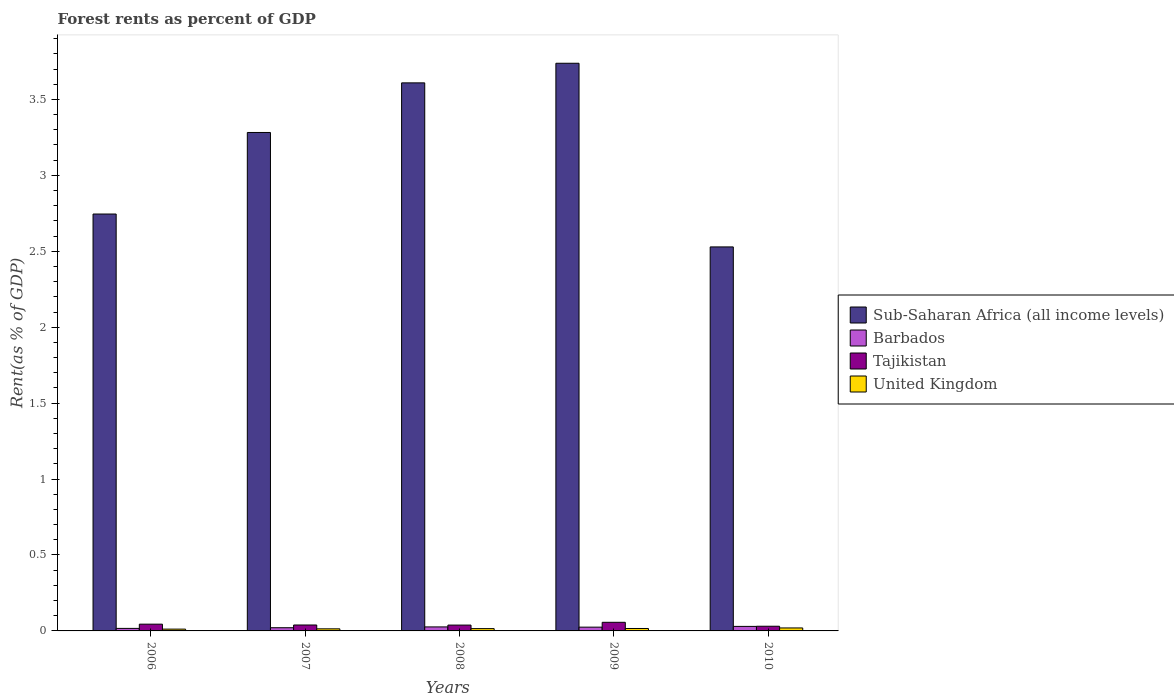How many groups of bars are there?
Provide a short and direct response. 5. How many bars are there on the 4th tick from the left?
Offer a terse response. 4. How many bars are there on the 1st tick from the right?
Ensure brevity in your answer.  4. What is the label of the 2nd group of bars from the left?
Offer a very short reply. 2007. In how many cases, is the number of bars for a given year not equal to the number of legend labels?
Offer a terse response. 0. What is the forest rent in Barbados in 2008?
Keep it short and to the point. 0.03. Across all years, what is the maximum forest rent in Tajikistan?
Your answer should be compact. 0.06. Across all years, what is the minimum forest rent in Sub-Saharan Africa (all income levels)?
Your answer should be very brief. 2.53. In which year was the forest rent in Sub-Saharan Africa (all income levels) maximum?
Provide a succinct answer. 2009. In which year was the forest rent in Barbados minimum?
Ensure brevity in your answer.  2006. What is the total forest rent in Tajikistan in the graph?
Your answer should be compact. 0.21. What is the difference between the forest rent in Barbados in 2008 and that in 2009?
Your answer should be compact. 0. What is the difference between the forest rent in Sub-Saharan Africa (all income levels) in 2010 and the forest rent in Barbados in 2006?
Offer a very short reply. 2.51. What is the average forest rent in Sub-Saharan Africa (all income levels) per year?
Offer a terse response. 3.18. In the year 2008, what is the difference between the forest rent in Barbados and forest rent in United Kingdom?
Ensure brevity in your answer.  0.01. What is the ratio of the forest rent in United Kingdom in 2008 to that in 2009?
Your answer should be very brief. 0.95. Is the difference between the forest rent in Barbados in 2007 and 2010 greater than the difference between the forest rent in United Kingdom in 2007 and 2010?
Your response must be concise. No. What is the difference between the highest and the second highest forest rent in United Kingdom?
Give a very brief answer. 0. What is the difference between the highest and the lowest forest rent in Tajikistan?
Your answer should be compact. 0.03. Is it the case that in every year, the sum of the forest rent in United Kingdom and forest rent in Tajikistan is greater than the sum of forest rent in Sub-Saharan Africa (all income levels) and forest rent in Barbados?
Offer a terse response. Yes. What does the 1st bar from the left in 2009 represents?
Offer a very short reply. Sub-Saharan Africa (all income levels). What does the 2nd bar from the right in 2008 represents?
Keep it short and to the point. Tajikistan. Is it the case that in every year, the sum of the forest rent in Barbados and forest rent in Sub-Saharan Africa (all income levels) is greater than the forest rent in United Kingdom?
Your response must be concise. Yes. Are all the bars in the graph horizontal?
Provide a short and direct response. No. What is the difference between two consecutive major ticks on the Y-axis?
Make the answer very short. 0.5. Are the values on the major ticks of Y-axis written in scientific E-notation?
Offer a very short reply. No. Does the graph contain any zero values?
Your answer should be compact. No. Where does the legend appear in the graph?
Give a very brief answer. Center right. How many legend labels are there?
Keep it short and to the point. 4. How are the legend labels stacked?
Your answer should be very brief. Vertical. What is the title of the graph?
Offer a very short reply. Forest rents as percent of GDP. Does "St. Kitts and Nevis" appear as one of the legend labels in the graph?
Offer a terse response. No. What is the label or title of the Y-axis?
Keep it short and to the point. Rent(as % of GDP). What is the Rent(as % of GDP) in Sub-Saharan Africa (all income levels) in 2006?
Offer a very short reply. 2.75. What is the Rent(as % of GDP) of Barbados in 2006?
Your answer should be compact. 0.02. What is the Rent(as % of GDP) in Tajikistan in 2006?
Give a very brief answer. 0.04. What is the Rent(as % of GDP) of United Kingdom in 2006?
Your answer should be compact. 0.01. What is the Rent(as % of GDP) in Sub-Saharan Africa (all income levels) in 2007?
Make the answer very short. 3.28. What is the Rent(as % of GDP) of Barbados in 2007?
Your response must be concise. 0.02. What is the Rent(as % of GDP) of Tajikistan in 2007?
Provide a short and direct response. 0.04. What is the Rent(as % of GDP) in United Kingdom in 2007?
Provide a succinct answer. 0.01. What is the Rent(as % of GDP) in Sub-Saharan Africa (all income levels) in 2008?
Make the answer very short. 3.61. What is the Rent(as % of GDP) in Barbados in 2008?
Make the answer very short. 0.03. What is the Rent(as % of GDP) in Tajikistan in 2008?
Ensure brevity in your answer.  0.04. What is the Rent(as % of GDP) in United Kingdom in 2008?
Your answer should be very brief. 0.02. What is the Rent(as % of GDP) in Sub-Saharan Africa (all income levels) in 2009?
Keep it short and to the point. 3.74. What is the Rent(as % of GDP) in Barbados in 2009?
Your response must be concise. 0.02. What is the Rent(as % of GDP) of Tajikistan in 2009?
Offer a terse response. 0.06. What is the Rent(as % of GDP) in United Kingdom in 2009?
Give a very brief answer. 0.02. What is the Rent(as % of GDP) in Sub-Saharan Africa (all income levels) in 2010?
Provide a succinct answer. 2.53. What is the Rent(as % of GDP) of Barbados in 2010?
Give a very brief answer. 0.03. What is the Rent(as % of GDP) in Tajikistan in 2010?
Keep it short and to the point. 0.03. What is the Rent(as % of GDP) of United Kingdom in 2010?
Your response must be concise. 0.02. Across all years, what is the maximum Rent(as % of GDP) in Sub-Saharan Africa (all income levels)?
Ensure brevity in your answer.  3.74. Across all years, what is the maximum Rent(as % of GDP) in Barbados?
Your answer should be very brief. 0.03. Across all years, what is the maximum Rent(as % of GDP) in Tajikistan?
Provide a short and direct response. 0.06. Across all years, what is the maximum Rent(as % of GDP) of United Kingdom?
Offer a very short reply. 0.02. Across all years, what is the minimum Rent(as % of GDP) of Sub-Saharan Africa (all income levels)?
Keep it short and to the point. 2.53. Across all years, what is the minimum Rent(as % of GDP) of Barbados?
Provide a succinct answer. 0.02. Across all years, what is the minimum Rent(as % of GDP) in Tajikistan?
Ensure brevity in your answer.  0.03. Across all years, what is the minimum Rent(as % of GDP) in United Kingdom?
Offer a very short reply. 0.01. What is the total Rent(as % of GDP) of Sub-Saharan Africa (all income levels) in the graph?
Ensure brevity in your answer.  15.9. What is the total Rent(as % of GDP) in Barbados in the graph?
Provide a succinct answer. 0.12. What is the total Rent(as % of GDP) in Tajikistan in the graph?
Your response must be concise. 0.21. What is the total Rent(as % of GDP) in United Kingdom in the graph?
Provide a short and direct response. 0.08. What is the difference between the Rent(as % of GDP) in Sub-Saharan Africa (all income levels) in 2006 and that in 2007?
Ensure brevity in your answer.  -0.54. What is the difference between the Rent(as % of GDP) in Barbados in 2006 and that in 2007?
Make the answer very short. -0. What is the difference between the Rent(as % of GDP) of Tajikistan in 2006 and that in 2007?
Give a very brief answer. 0.01. What is the difference between the Rent(as % of GDP) of United Kingdom in 2006 and that in 2007?
Keep it short and to the point. -0. What is the difference between the Rent(as % of GDP) in Sub-Saharan Africa (all income levels) in 2006 and that in 2008?
Keep it short and to the point. -0.86. What is the difference between the Rent(as % of GDP) in Barbados in 2006 and that in 2008?
Your answer should be compact. -0.01. What is the difference between the Rent(as % of GDP) in Tajikistan in 2006 and that in 2008?
Your answer should be very brief. 0.01. What is the difference between the Rent(as % of GDP) in United Kingdom in 2006 and that in 2008?
Offer a very short reply. -0. What is the difference between the Rent(as % of GDP) of Sub-Saharan Africa (all income levels) in 2006 and that in 2009?
Ensure brevity in your answer.  -0.99. What is the difference between the Rent(as % of GDP) in Barbados in 2006 and that in 2009?
Ensure brevity in your answer.  -0.01. What is the difference between the Rent(as % of GDP) in Tajikistan in 2006 and that in 2009?
Your answer should be compact. -0.01. What is the difference between the Rent(as % of GDP) in United Kingdom in 2006 and that in 2009?
Offer a very short reply. -0. What is the difference between the Rent(as % of GDP) of Sub-Saharan Africa (all income levels) in 2006 and that in 2010?
Offer a terse response. 0.22. What is the difference between the Rent(as % of GDP) in Barbados in 2006 and that in 2010?
Make the answer very short. -0.01. What is the difference between the Rent(as % of GDP) in Tajikistan in 2006 and that in 2010?
Keep it short and to the point. 0.01. What is the difference between the Rent(as % of GDP) in United Kingdom in 2006 and that in 2010?
Give a very brief answer. -0.01. What is the difference between the Rent(as % of GDP) of Sub-Saharan Africa (all income levels) in 2007 and that in 2008?
Give a very brief answer. -0.33. What is the difference between the Rent(as % of GDP) of Barbados in 2007 and that in 2008?
Keep it short and to the point. -0.01. What is the difference between the Rent(as % of GDP) in Tajikistan in 2007 and that in 2008?
Your answer should be very brief. 0. What is the difference between the Rent(as % of GDP) in United Kingdom in 2007 and that in 2008?
Keep it short and to the point. -0. What is the difference between the Rent(as % of GDP) of Sub-Saharan Africa (all income levels) in 2007 and that in 2009?
Your answer should be compact. -0.46. What is the difference between the Rent(as % of GDP) of Barbados in 2007 and that in 2009?
Offer a terse response. -0. What is the difference between the Rent(as % of GDP) of Tajikistan in 2007 and that in 2009?
Provide a succinct answer. -0.02. What is the difference between the Rent(as % of GDP) in United Kingdom in 2007 and that in 2009?
Your answer should be compact. -0. What is the difference between the Rent(as % of GDP) of Sub-Saharan Africa (all income levels) in 2007 and that in 2010?
Ensure brevity in your answer.  0.75. What is the difference between the Rent(as % of GDP) of Barbados in 2007 and that in 2010?
Your answer should be compact. -0.01. What is the difference between the Rent(as % of GDP) in Tajikistan in 2007 and that in 2010?
Make the answer very short. 0.01. What is the difference between the Rent(as % of GDP) of United Kingdom in 2007 and that in 2010?
Offer a very short reply. -0.01. What is the difference between the Rent(as % of GDP) in Sub-Saharan Africa (all income levels) in 2008 and that in 2009?
Offer a very short reply. -0.13. What is the difference between the Rent(as % of GDP) in Barbados in 2008 and that in 2009?
Offer a very short reply. 0. What is the difference between the Rent(as % of GDP) of Tajikistan in 2008 and that in 2009?
Give a very brief answer. -0.02. What is the difference between the Rent(as % of GDP) of United Kingdom in 2008 and that in 2009?
Make the answer very short. -0. What is the difference between the Rent(as % of GDP) in Sub-Saharan Africa (all income levels) in 2008 and that in 2010?
Your answer should be very brief. 1.08. What is the difference between the Rent(as % of GDP) in Barbados in 2008 and that in 2010?
Provide a short and direct response. -0. What is the difference between the Rent(as % of GDP) of Tajikistan in 2008 and that in 2010?
Provide a short and direct response. 0.01. What is the difference between the Rent(as % of GDP) in United Kingdom in 2008 and that in 2010?
Provide a short and direct response. -0. What is the difference between the Rent(as % of GDP) in Sub-Saharan Africa (all income levels) in 2009 and that in 2010?
Make the answer very short. 1.21. What is the difference between the Rent(as % of GDP) in Barbados in 2009 and that in 2010?
Offer a very short reply. -0. What is the difference between the Rent(as % of GDP) of Tajikistan in 2009 and that in 2010?
Ensure brevity in your answer.  0.03. What is the difference between the Rent(as % of GDP) in United Kingdom in 2009 and that in 2010?
Offer a terse response. -0. What is the difference between the Rent(as % of GDP) in Sub-Saharan Africa (all income levels) in 2006 and the Rent(as % of GDP) in Barbados in 2007?
Your answer should be very brief. 2.72. What is the difference between the Rent(as % of GDP) in Sub-Saharan Africa (all income levels) in 2006 and the Rent(as % of GDP) in Tajikistan in 2007?
Provide a succinct answer. 2.71. What is the difference between the Rent(as % of GDP) in Sub-Saharan Africa (all income levels) in 2006 and the Rent(as % of GDP) in United Kingdom in 2007?
Your answer should be compact. 2.73. What is the difference between the Rent(as % of GDP) in Barbados in 2006 and the Rent(as % of GDP) in Tajikistan in 2007?
Your answer should be very brief. -0.02. What is the difference between the Rent(as % of GDP) in Barbados in 2006 and the Rent(as % of GDP) in United Kingdom in 2007?
Make the answer very short. 0. What is the difference between the Rent(as % of GDP) of Tajikistan in 2006 and the Rent(as % of GDP) of United Kingdom in 2007?
Provide a succinct answer. 0.03. What is the difference between the Rent(as % of GDP) of Sub-Saharan Africa (all income levels) in 2006 and the Rent(as % of GDP) of Barbados in 2008?
Your answer should be very brief. 2.72. What is the difference between the Rent(as % of GDP) of Sub-Saharan Africa (all income levels) in 2006 and the Rent(as % of GDP) of Tajikistan in 2008?
Your answer should be compact. 2.71. What is the difference between the Rent(as % of GDP) in Sub-Saharan Africa (all income levels) in 2006 and the Rent(as % of GDP) in United Kingdom in 2008?
Ensure brevity in your answer.  2.73. What is the difference between the Rent(as % of GDP) of Barbados in 2006 and the Rent(as % of GDP) of Tajikistan in 2008?
Make the answer very short. -0.02. What is the difference between the Rent(as % of GDP) of Barbados in 2006 and the Rent(as % of GDP) of United Kingdom in 2008?
Ensure brevity in your answer.  0. What is the difference between the Rent(as % of GDP) in Tajikistan in 2006 and the Rent(as % of GDP) in United Kingdom in 2008?
Your answer should be compact. 0.03. What is the difference between the Rent(as % of GDP) in Sub-Saharan Africa (all income levels) in 2006 and the Rent(as % of GDP) in Barbados in 2009?
Your response must be concise. 2.72. What is the difference between the Rent(as % of GDP) in Sub-Saharan Africa (all income levels) in 2006 and the Rent(as % of GDP) in Tajikistan in 2009?
Your answer should be very brief. 2.69. What is the difference between the Rent(as % of GDP) in Sub-Saharan Africa (all income levels) in 2006 and the Rent(as % of GDP) in United Kingdom in 2009?
Your response must be concise. 2.73. What is the difference between the Rent(as % of GDP) of Barbados in 2006 and the Rent(as % of GDP) of Tajikistan in 2009?
Your answer should be compact. -0.04. What is the difference between the Rent(as % of GDP) of Barbados in 2006 and the Rent(as % of GDP) of United Kingdom in 2009?
Give a very brief answer. 0. What is the difference between the Rent(as % of GDP) of Tajikistan in 2006 and the Rent(as % of GDP) of United Kingdom in 2009?
Make the answer very short. 0.03. What is the difference between the Rent(as % of GDP) of Sub-Saharan Africa (all income levels) in 2006 and the Rent(as % of GDP) of Barbados in 2010?
Your answer should be very brief. 2.72. What is the difference between the Rent(as % of GDP) of Sub-Saharan Africa (all income levels) in 2006 and the Rent(as % of GDP) of Tajikistan in 2010?
Your answer should be compact. 2.71. What is the difference between the Rent(as % of GDP) of Sub-Saharan Africa (all income levels) in 2006 and the Rent(as % of GDP) of United Kingdom in 2010?
Provide a short and direct response. 2.73. What is the difference between the Rent(as % of GDP) in Barbados in 2006 and the Rent(as % of GDP) in Tajikistan in 2010?
Offer a very short reply. -0.01. What is the difference between the Rent(as % of GDP) in Barbados in 2006 and the Rent(as % of GDP) in United Kingdom in 2010?
Offer a terse response. -0. What is the difference between the Rent(as % of GDP) of Tajikistan in 2006 and the Rent(as % of GDP) of United Kingdom in 2010?
Provide a succinct answer. 0.02. What is the difference between the Rent(as % of GDP) in Sub-Saharan Africa (all income levels) in 2007 and the Rent(as % of GDP) in Barbados in 2008?
Your answer should be very brief. 3.26. What is the difference between the Rent(as % of GDP) of Sub-Saharan Africa (all income levels) in 2007 and the Rent(as % of GDP) of Tajikistan in 2008?
Your answer should be very brief. 3.24. What is the difference between the Rent(as % of GDP) of Sub-Saharan Africa (all income levels) in 2007 and the Rent(as % of GDP) of United Kingdom in 2008?
Your response must be concise. 3.27. What is the difference between the Rent(as % of GDP) in Barbados in 2007 and the Rent(as % of GDP) in Tajikistan in 2008?
Give a very brief answer. -0.02. What is the difference between the Rent(as % of GDP) of Barbados in 2007 and the Rent(as % of GDP) of United Kingdom in 2008?
Provide a short and direct response. 0.01. What is the difference between the Rent(as % of GDP) of Tajikistan in 2007 and the Rent(as % of GDP) of United Kingdom in 2008?
Provide a succinct answer. 0.02. What is the difference between the Rent(as % of GDP) in Sub-Saharan Africa (all income levels) in 2007 and the Rent(as % of GDP) in Barbados in 2009?
Keep it short and to the point. 3.26. What is the difference between the Rent(as % of GDP) in Sub-Saharan Africa (all income levels) in 2007 and the Rent(as % of GDP) in Tajikistan in 2009?
Ensure brevity in your answer.  3.23. What is the difference between the Rent(as % of GDP) in Sub-Saharan Africa (all income levels) in 2007 and the Rent(as % of GDP) in United Kingdom in 2009?
Make the answer very short. 3.27. What is the difference between the Rent(as % of GDP) in Barbados in 2007 and the Rent(as % of GDP) in Tajikistan in 2009?
Give a very brief answer. -0.04. What is the difference between the Rent(as % of GDP) of Barbados in 2007 and the Rent(as % of GDP) of United Kingdom in 2009?
Provide a succinct answer. 0.01. What is the difference between the Rent(as % of GDP) in Tajikistan in 2007 and the Rent(as % of GDP) in United Kingdom in 2009?
Provide a succinct answer. 0.02. What is the difference between the Rent(as % of GDP) in Sub-Saharan Africa (all income levels) in 2007 and the Rent(as % of GDP) in Barbados in 2010?
Offer a very short reply. 3.25. What is the difference between the Rent(as % of GDP) in Sub-Saharan Africa (all income levels) in 2007 and the Rent(as % of GDP) in Tajikistan in 2010?
Your answer should be compact. 3.25. What is the difference between the Rent(as % of GDP) in Sub-Saharan Africa (all income levels) in 2007 and the Rent(as % of GDP) in United Kingdom in 2010?
Offer a very short reply. 3.26. What is the difference between the Rent(as % of GDP) in Barbados in 2007 and the Rent(as % of GDP) in Tajikistan in 2010?
Your answer should be very brief. -0.01. What is the difference between the Rent(as % of GDP) of Barbados in 2007 and the Rent(as % of GDP) of United Kingdom in 2010?
Ensure brevity in your answer.  0. What is the difference between the Rent(as % of GDP) of Tajikistan in 2007 and the Rent(as % of GDP) of United Kingdom in 2010?
Offer a terse response. 0.02. What is the difference between the Rent(as % of GDP) of Sub-Saharan Africa (all income levels) in 2008 and the Rent(as % of GDP) of Barbados in 2009?
Provide a short and direct response. 3.58. What is the difference between the Rent(as % of GDP) in Sub-Saharan Africa (all income levels) in 2008 and the Rent(as % of GDP) in Tajikistan in 2009?
Offer a very short reply. 3.55. What is the difference between the Rent(as % of GDP) in Sub-Saharan Africa (all income levels) in 2008 and the Rent(as % of GDP) in United Kingdom in 2009?
Make the answer very short. 3.59. What is the difference between the Rent(as % of GDP) of Barbados in 2008 and the Rent(as % of GDP) of Tajikistan in 2009?
Give a very brief answer. -0.03. What is the difference between the Rent(as % of GDP) in Barbados in 2008 and the Rent(as % of GDP) in United Kingdom in 2009?
Ensure brevity in your answer.  0.01. What is the difference between the Rent(as % of GDP) in Tajikistan in 2008 and the Rent(as % of GDP) in United Kingdom in 2009?
Your answer should be very brief. 0.02. What is the difference between the Rent(as % of GDP) in Sub-Saharan Africa (all income levels) in 2008 and the Rent(as % of GDP) in Barbados in 2010?
Offer a very short reply. 3.58. What is the difference between the Rent(as % of GDP) in Sub-Saharan Africa (all income levels) in 2008 and the Rent(as % of GDP) in Tajikistan in 2010?
Your answer should be very brief. 3.58. What is the difference between the Rent(as % of GDP) of Sub-Saharan Africa (all income levels) in 2008 and the Rent(as % of GDP) of United Kingdom in 2010?
Your answer should be compact. 3.59. What is the difference between the Rent(as % of GDP) of Barbados in 2008 and the Rent(as % of GDP) of Tajikistan in 2010?
Offer a very short reply. -0. What is the difference between the Rent(as % of GDP) in Barbados in 2008 and the Rent(as % of GDP) in United Kingdom in 2010?
Your answer should be very brief. 0.01. What is the difference between the Rent(as % of GDP) in Tajikistan in 2008 and the Rent(as % of GDP) in United Kingdom in 2010?
Keep it short and to the point. 0.02. What is the difference between the Rent(as % of GDP) of Sub-Saharan Africa (all income levels) in 2009 and the Rent(as % of GDP) of Barbados in 2010?
Keep it short and to the point. 3.71. What is the difference between the Rent(as % of GDP) of Sub-Saharan Africa (all income levels) in 2009 and the Rent(as % of GDP) of Tajikistan in 2010?
Offer a terse response. 3.71. What is the difference between the Rent(as % of GDP) of Sub-Saharan Africa (all income levels) in 2009 and the Rent(as % of GDP) of United Kingdom in 2010?
Provide a short and direct response. 3.72. What is the difference between the Rent(as % of GDP) in Barbados in 2009 and the Rent(as % of GDP) in Tajikistan in 2010?
Give a very brief answer. -0.01. What is the difference between the Rent(as % of GDP) of Barbados in 2009 and the Rent(as % of GDP) of United Kingdom in 2010?
Give a very brief answer. 0.01. What is the difference between the Rent(as % of GDP) in Tajikistan in 2009 and the Rent(as % of GDP) in United Kingdom in 2010?
Your response must be concise. 0.04. What is the average Rent(as % of GDP) of Sub-Saharan Africa (all income levels) per year?
Offer a very short reply. 3.18. What is the average Rent(as % of GDP) of Barbados per year?
Ensure brevity in your answer.  0.02. What is the average Rent(as % of GDP) in Tajikistan per year?
Your response must be concise. 0.04. What is the average Rent(as % of GDP) of United Kingdom per year?
Ensure brevity in your answer.  0.02. In the year 2006, what is the difference between the Rent(as % of GDP) of Sub-Saharan Africa (all income levels) and Rent(as % of GDP) of Barbados?
Your answer should be compact. 2.73. In the year 2006, what is the difference between the Rent(as % of GDP) of Sub-Saharan Africa (all income levels) and Rent(as % of GDP) of Tajikistan?
Your answer should be compact. 2.7. In the year 2006, what is the difference between the Rent(as % of GDP) of Sub-Saharan Africa (all income levels) and Rent(as % of GDP) of United Kingdom?
Make the answer very short. 2.73. In the year 2006, what is the difference between the Rent(as % of GDP) of Barbados and Rent(as % of GDP) of Tajikistan?
Offer a very short reply. -0.03. In the year 2006, what is the difference between the Rent(as % of GDP) in Barbados and Rent(as % of GDP) in United Kingdom?
Offer a terse response. 0. In the year 2006, what is the difference between the Rent(as % of GDP) of Tajikistan and Rent(as % of GDP) of United Kingdom?
Offer a terse response. 0.03. In the year 2007, what is the difference between the Rent(as % of GDP) in Sub-Saharan Africa (all income levels) and Rent(as % of GDP) in Barbados?
Provide a succinct answer. 3.26. In the year 2007, what is the difference between the Rent(as % of GDP) in Sub-Saharan Africa (all income levels) and Rent(as % of GDP) in Tajikistan?
Offer a terse response. 3.24. In the year 2007, what is the difference between the Rent(as % of GDP) in Sub-Saharan Africa (all income levels) and Rent(as % of GDP) in United Kingdom?
Provide a succinct answer. 3.27. In the year 2007, what is the difference between the Rent(as % of GDP) of Barbados and Rent(as % of GDP) of Tajikistan?
Your response must be concise. -0.02. In the year 2007, what is the difference between the Rent(as % of GDP) in Barbados and Rent(as % of GDP) in United Kingdom?
Your answer should be very brief. 0.01. In the year 2007, what is the difference between the Rent(as % of GDP) in Tajikistan and Rent(as % of GDP) in United Kingdom?
Ensure brevity in your answer.  0.03. In the year 2008, what is the difference between the Rent(as % of GDP) in Sub-Saharan Africa (all income levels) and Rent(as % of GDP) in Barbados?
Ensure brevity in your answer.  3.58. In the year 2008, what is the difference between the Rent(as % of GDP) of Sub-Saharan Africa (all income levels) and Rent(as % of GDP) of Tajikistan?
Keep it short and to the point. 3.57. In the year 2008, what is the difference between the Rent(as % of GDP) of Sub-Saharan Africa (all income levels) and Rent(as % of GDP) of United Kingdom?
Your response must be concise. 3.59. In the year 2008, what is the difference between the Rent(as % of GDP) of Barbados and Rent(as % of GDP) of Tajikistan?
Provide a succinct answer. -0.01. In the year 2008, what is the difference between the Rent(as % of GDP) of Barbados and Rent(as % of GDP) of United Kingdom?
Keep it short and to the point. 0.01. In the year 2008, what is the difference between the Rent(as % of GDP) of Tajikistan and Rent(as % of GDP) of United Kingdom?
Your answer should be very brief. 0.02. In the year 2009, what is the difference between the Rent(as % of GDP) in Sub-Saharan Africa (all income levels) and Rent(as % of GDP) in Barbados?
Offer a terse response. 3.71. In the year 2009, what is the difference between the Rent(as % of GDP) of Sub-Saharan Africa (all income levels) and Rent(as % of GDP) of Tajikistan?
Keep it short and to the point. 3.68. In the year 2009, what is the difference between the Rent(as % of GDP) in Sub-Saharan Africa (all income levels) and Rent(as % of GDP) in United Kingdom?
Your answer should be very brief. 3.72. In the year 2009, what is the difference between the Rent(as % of GDP) of Barbados and Rent(as % of GDP) of Tajikistan?
Offer a very short reply. -0.03. In the year 2009, what is the difference between the Rent(as % of GDP) of Barbados and Rent(as % of GDP) of United Kingdom?
Your answer should be compact. 0.01. In the year 2009, what is the difference between the Rent(as % of GDP) in Tajikistan and Rent(as % of GDP) in United Kingdom?
Keep it short and to the point. 0.04. In the year 2010, what is the difference between the Rent(as % of GDP) in Sub-Saharan Africa (all income levels) and Rent(as % of GDP) in Barbados?
Ensure brevity in your answer.  2.5. In the year 2010, what is the difference between the Rent(as % of GDP) in Sub-Saharan Africa (all income levels) and Rent(as % of GDP) in Tajikistan?
Provide a succinct answer. 2.5. In the year 2010, what is the difference between the Rent(as % of GDP) in Sub-Saharan Africa (all income levels) and Rent(as % of GDP) in United Kingdom?
Keep it short and to the point. 2.51. In the year 2010, what is the difference between the Rent(as % of GDP) of Barbados and Rent(as % of GDP) of Tajikistan?
Your answer should be compact. -0. In the year 2010, what is the difference between the Rent(as % of GDP) in Barbados and Rent(as % of GDP) in United Kingdom?
Give a very brief answer. 0.01. In the year 2010, what is the difference between the Rent(as % of GDP) of Tajikistan and Rent(as % of GDP) of United Kingdom?
Ensure brevity in your answer.  0.01. What is the ratio of the Rent(as % of GDP) of Sub-Saharan Africa (all income levels) in 2006 to that in 2007?
Provide a succinct answer. 0.84. What is the ratio of the Rent(as % of GDP) in Barbados in 2006 to that in 2007?
Your answer should be compact. 0.79. What is the ratio of the Rent(as % of GDP) of Tajikistan in 2006 to that in 2007?
Offer a very short reply. 1.14. What is the ratio of the Rent(as % of GDP) of United Kingdom in 2006 to that in 2007?
Your response must be concise. 0.87. What is the ratio of the Rent(as % of GDP) in Sub-Saharan Africa (all income levels) in 2006 to that in 2008?
Your response must be concise. 0.76. What is the ratio of the Rent(as % of GDP) in Barbados in 2006 to that in 2008?
Your response must be concise. 0.63. What is the ratio of the Rent(as % of GDP) of Tajikistan in 2006 to that in 2008?
Ensure brevity in your answer.  1.16. What is the ratio of the Rent(as % of GDP) in United Kingdom in 2006 to that in 2008?
Your answer should be very brief. 0.79. What is the ratio of the Rent(as % of GDP) in Sub-Saharan Africa (all income levels) in 2006 to that in 2009?
Your answer should be compact. 0.73. What is the ratio of the Rent(as % of GDP) of Barbados in 2006 to that in 2009?
Provide a short and direct response. 0.67. What is the ratio of the Rent(as % of GDP) of Tajikistan in 2006 to that in 2009?
Offer a terse response. 0.78. What is the ratio of the Rent(as % of GDP) of United Kingdom in 2006 to that in 2009?
Your response must be concise. 0.74. What is the ratio of the Rent(as % of GDP) in Sub-Saharan Africa (all income levels) in 2006 to that in 2010?
Your response must be concise. 1.09. What is the ratio of the Rent(as % of GDP) of Barbados in 2006 to that in 2010?
Provide a short and direct response. 0.56. What is the ratio of the Rent(as % of GDP) in Tajikistan in 2006 to that in 2010?
Offer a terse response. 1.44. What is the ratio of the Rent(as % of GDP) of United Kingdom in 2006 to that in 2010?
Keep it short and to the point. 0.61. What is the ratio of the Rent(as % of GDP) in Sub-Saharan Africa (all income levels) in 2007 to that in 2008?
Make the answer very short. 0.91. What is the ratio of the Rent(as % of GDP) of Barbados in 2007 to that in 2008?
Offer a very short reply. 0.8. What is the ratio of the Rent(as % of GDP) of Tajikistan in 2007 to that in 2008?
Ensure brevity in your answer.  1.02. What is the ratio of the Rent(as % of GDP) in United Kingdom in 2007 to that in 2008?
Provide a short and direct response. 0.9. What is the ratio of the Rent(as % of GDP) in Sub-Saharan Africa (all income levels) in 2007 to that in 2009?
Give a very brief answer. 0.88. What is the ratio of the Rent(as % of GDP) in Barbados in 2007 to that in 2009?
Your answer should be very brief. 0.85. What is the ratio of the Rent(as % of GDP) of Tajikistan in 2007 to that in 2009?
Ensure brevity in your answer.  0.69. What is the ratio of the Rent(as % of GDP) of United Kingdom in 2007 to that in 2009?
Ensure brevity in your answer.  0.86. What is the ratio of the Rent(as % of GDP) of Sub-Saharan Africa (all income levels) in 2007 to that in 2010?
Give a very brief answer. 1.3. What is the ratio of the Rent(as % of GDP) of Barbados in 2007 to that in 2010?
Ensure brevity in your answer.  0.71. What is the ratio of the Rent(as % of GDP) in Tajikistan in 2007 to that in 2010?
Your answer should be compact. 1.27. What is the ratio of the Rent(as % of GDP) in United Kingdom in 2007 to that in 2010?
Ensure brevity in your answer.  0.7. What is the ratio of the Rent(as % of GDP) of Sub-Saharan Africa (all income levels) in 2008 to that in 2009?
Offer a very short reply. 0.97. What is the ratio of the Rent(as % of GDP) of Barbados in 2008 to that in 2009?
Ensure brevity in your answer.  1.06. What is the ratio of the Rent(as % of GDP) in Tajikistan in 2008 to that in 2009?
Your response must be concise. 0.68. What is the ratio of the Rent(as % of GDP) in United Kingdom in 2008 to that in 2009?
Your response must be concise. 0.95. What is the ratio of the Rent(as % of GDP) in Sub-Saharan Africa (all income levels) in 2008 to that in 2010?
Make the answer very short. 1.43. What is the ratio of the Rent(as % of GDP) of Barbados in 2008 to that in 2010?
Your answer should be very brief. 0.89. What is the ratio of the Rent(as % of GDP) of Tajikistan in 2008 to that in 2010?
Provide a succinct answer. 1.25. What is the ratio of the Rent(as % of GDP) in United Kingdom in 2008 to that in 2010?
Give a very brief answer. 0.78. What is the ratio of the Rent(as % of GDP) of Sub-Saharan Africa (all income levels) in 2009 to that in 2010?
Provide a short and direct response. 1.48. What is the ratio of the Rent(as % of GDP) of Barbados in 2009 to that in 2010?
Provide a succinct answer. 0.84. What is the ratio of the Rent(as % of GDP) in Tajikistan in 2009 to that in 2010?
Offer a very short reply. 1.84. What is the ratio of the Rent(as % of GDP) of United Kingdom in 2009 to that in 2010?
Keep it short and to the point. 0.82. What is the difference between the highest and the second highest Rent(as % of GDP) in Sub-Saharan Africa (all income levels)?
Offer a very short reply. 0.13. What is the difference between the highest and the second highest Rent(as % of GDP) in Barbados?
Offer a very short reply. 0. What is the difference between the highest and the second highest Rent(as % of GDP) in Tajikistan?
Provide a short and direct response. 0.01. What is the difference between the highest and the second highest Rent(as % of GDP) of United Kingdom?
Offer a very short reply. 0. What is the difference between the highest and the lowest Rent(as % of GDP) in Sub-Saharan Africa (all income levels)?
Provide a short and direct response. 1.21. What is the difference between the highest and the lowest Rent(as % of GDP) in Barbados?
Ensure brevity in your answer.  0.01. What is the difference between the highest and the lowest Rent(as % of GDP) of Tajikistan?
Your answer should be very brief. 0.03. What is the difference between the highest and the lowest Rent(as % of GDP) of United Kingdom?
Offer a very short reply. 0.01. 